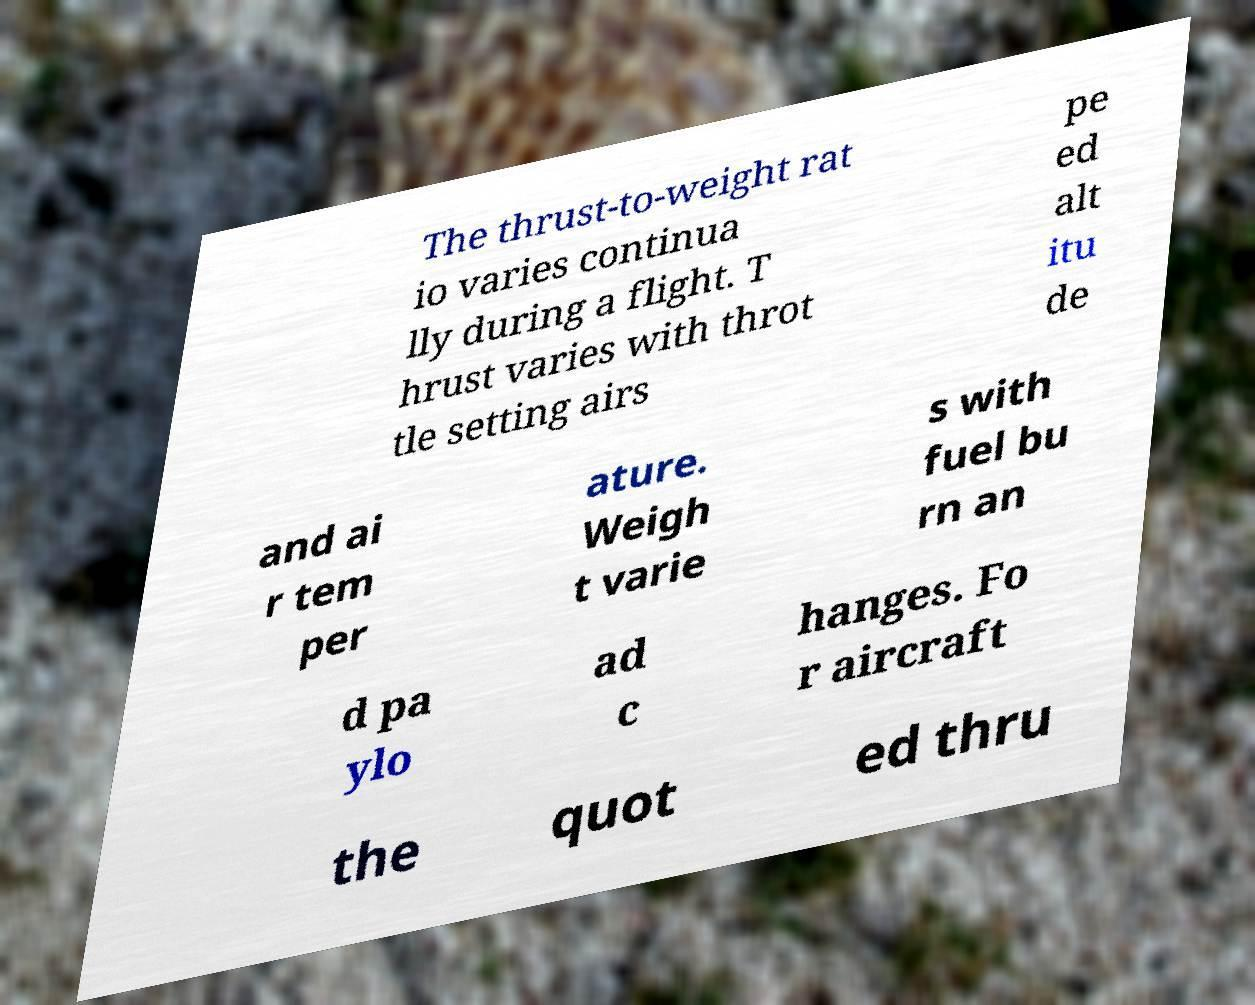Could you extract and type out the text from this image? The thrust-to-weight rat io varies continua lly during a flight. T hrust varies with throt tle setting airs pe ed alt itu de and ai r tem per ature. Weigh t varie s with fuel bu rn an d pa ylo ad c hanges. Fo r aircraft the quot ed thru 